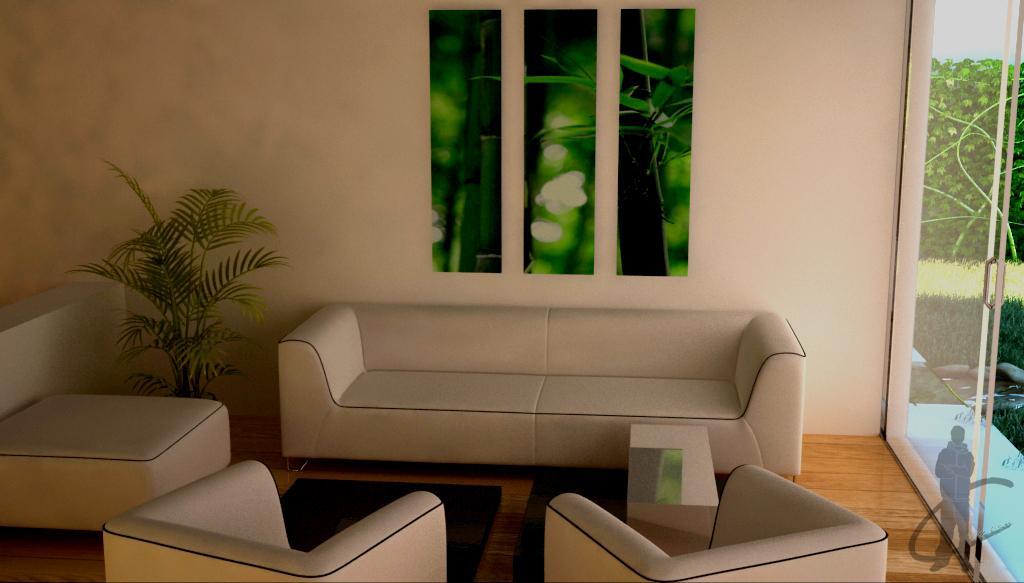Please provide a concise description of this image. This is a room which has a sofa set and the plant beside the sofa and a wall posture and also a window from which we can see the grass and small plants out side the room. 